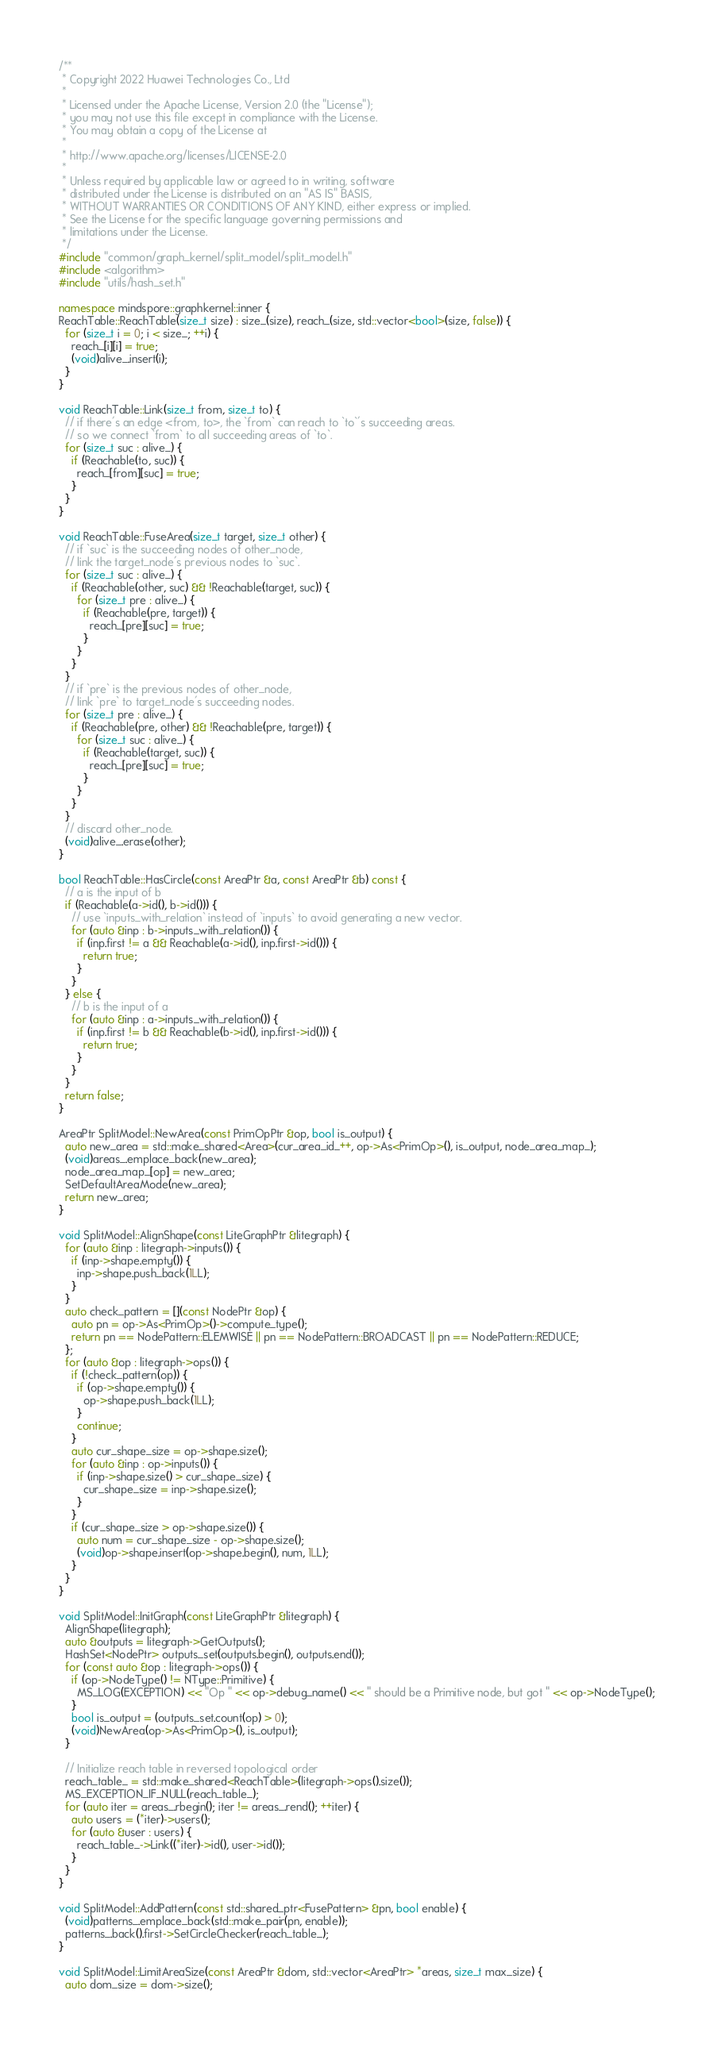Convert code to text. <code><loc_0><loc_0><loc_500><loc_500><_C++_>/**
 * Copyright 2022 Huawei Technologies Co., Ltd
 *
 * Licensed under the Apache License, Version 2.0 (the "License");
 * you may not use this file except in compliance with the License.
 * You may obtain a copy of the License at
 *
 * http://www.apache.org/licenses/LICENSE-2.0
 *
 * Unless required by applicable law or agreed to in writing, software
 * distributed under the License is distributed on an "AS IS" BASIS,
 * WITHOUT WARRANTIES OR CONDITIONS OF ANY KIND, either express or implied.
 * See the License for the specific language governing permissions and
 * limitations under the License.
 */
#include "common/graph_kernel/split_model/split_model.h"
#include <algorithm>
#include "utils/hash_set.h"

namespace mindspore::graphkernel::inner {
ReachTable::ReachTable(size_t size) : size_(size), reach_(size, std::vector<bool>(size, false)) {
  for (size_t i = 0; i < size_; ++i) {
    reach_[i][i] = true;
    (void)alive_.insert(i);
  }
}

void ReachTable::Link(size_t from, size_t to) {
  // if there's an edge <from, to>, the `from` can reach to `to`'s succeeding areas.
  // so we connect `from` to all succeeding areas of `to`.
  for (size_t suc : alive_) {
    if (Reachable(to, suc)) {
      reach_[from][suc] = true;
    }
  }
}

void ReachTable::FuseArea(size_t target, size_t other) {
  // if `suc` is the succeeding nodes of other_node,
  // link the target_node's previous nodes to `suc`.
  for (size_t suc : alive_) {
    if (Reachable(other, suc) && !Reachable(target, suc)) {
      for (size_t pre : alive_) {
        if (Reachable(pre, target)) {
          reach_[pre][suc] = true;
        }
      }
    }
  }
  // if `pre` is the previous nodes of other_node,
  // link `pre` to target_node's succeeding nodes.
  for (size_t pre : alive_) {
    if (Reachable(pre, other) && !Reachable(pre, target)) {
      for (size_t suc : alive_) {
        if (Reachable(target, suc)) {
          reach_[pre][suc] = true;
        }
      }
    }
  }
  // discard other_node.
  (void)alive_.erase(other);
}

bool ReachTable::HasCircle(const AreaPtr &a, const AreaPtr &b) const {
  // a is the input of b
  if (Reachable(a->id(), b->id())) {
    // use `inputs_with_relation` instead of `inputs` to avoid generating a new vector.
    for (auto &inp : b->inputs_with_relation()) {
      if (inp.first != a && Reachable(a->id(), inp.first->id())) {
        return true;
      }
    }
  } else {
    // b is the input of a
    for (auto &inp : a->inputs_with_relation()) {
      if (inp.first != b && Reachable(b->id(), inp.first->id())) {
        return true;
      }
    }
  }
  return false;
}

AreaPtr SplitModel::NewArea(const PrimOpPtr &op, bool is_output) {
  auto new_area = std::make_shared<Area>(cur_area_id_++, op->As<PrimOp>(), is_output, node_area_map_);
  (void)areas_.emplace_back(new_area);
  node_area_map_[op] = new_area;
  SetDefaultAreaMode(new_area);
  return new_area;
}

void SplitModel::AlignShape(const LiteGraphPtr &litegraph) {
  for (auto &inp : litegraph->inputs()) {
    if (inp->shape.empty()) {
      inp->shape.push_back(1LL);
    }
  }
  auto check_pattern = [](const NodePtr &op) {
    auto pn = op->As<PrimOp>()->compute_type();
    return pn == NodePattern::ELEMWISE || pn == NodePattern::BROADCAST || pn == NodePattern::REDUCE;
  };
  for (auto &op : litegraph->ops()) {
    if (!check_pattern(op)) {
      if (op->shape.empty()) {
        op->shape.push_back(1LL);
      }
      continue;
    }
    auto cur_shape_size = op->shape.size();
    for (auto &inp : op->inputs()) {
      if (inp->shape.size() > cur_shape_size) {
        cur_shape_size = inp->shape.size();
      }
    }
    if (cur_shape_size > op->shape.size()) {
      auto num = cur_shape_size - op->shape.size();
      (void)op->shape.insert(op->shape.begin(), num, 1LL);
    }
  }
}

void SplitModel::InitGraph(const LiteGraphPtr &litegraph) {
  AlignShape(litegraph);
  auto &outputs = litegraph->GetOutputs();
  HashSet<NodePtr> outputs_set(outputs.begin(), outputs.end());
  for (const auto &op : litegraph->ops()) {
    if (op->NodeType() != NType::Primitive) {
      MS_LOG(EXCEPTION) << "Op " << op->debug_name() << " should be a Primitive node, but got " << op->NodeType();
    }
    bool is_output = (outputs_set.count(op) > 0);
    (void)NewArea(op->As<PrimOp>(), is_output);
  }

  // Initialize reach table in reversed topological order
  reach_table_ = std::make_shared<ReachTable>(litegraph->ops().size());
  MS_EXCEPTION_IF_NULL(reach_table_);
  for (auto iter = areas_.rbegin(); iter != areas_.rend(); ++iter) {
    auto users = (*iter)->users();
    for (auto &user : users) {
      reach_table_->Link((*iter)->id(), user->id());
    }
  }
}

void SplitModel::AddPattern(const std::shared_ptr<FusePattern> &pn, bool enable) {
  (void)patterns_.emplace_back(std::make_pair(pn, enable));
  patterns_.back().first->SetCircleChecker(reach_table_);
}

void SplitModel::LimitAreaSize(const AreaPtr &dom, std::vector<AreaPtr> *areas, size_t max_size) {
  auto dom_size = dom->size();</code> 